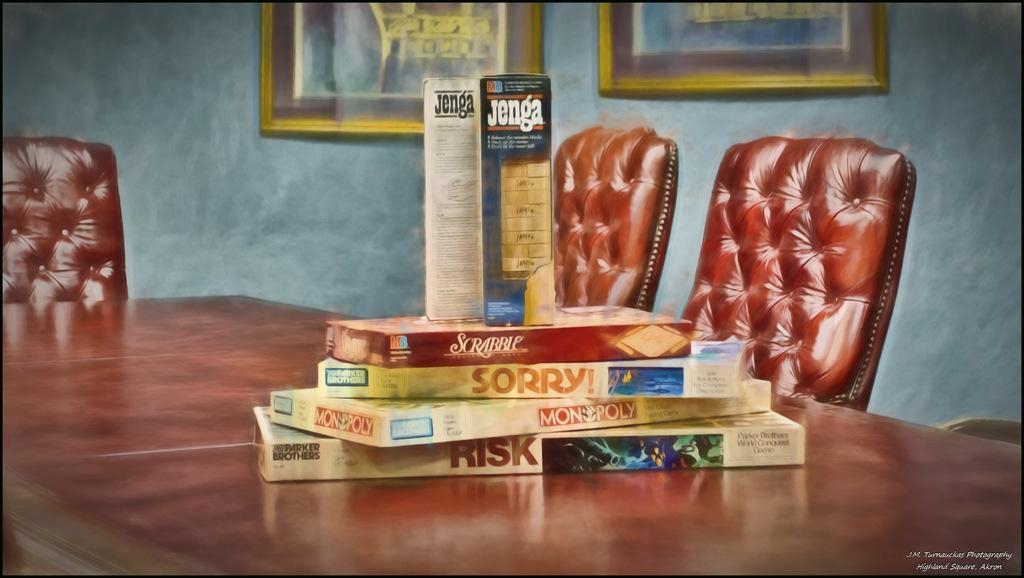Can you describe this image briefly? There is a table and there are some books kept upon the table, there are three chairs around the table and in the background there is a wall and there are two photo frames attached to the wall. All these things are picturized in a painting. 